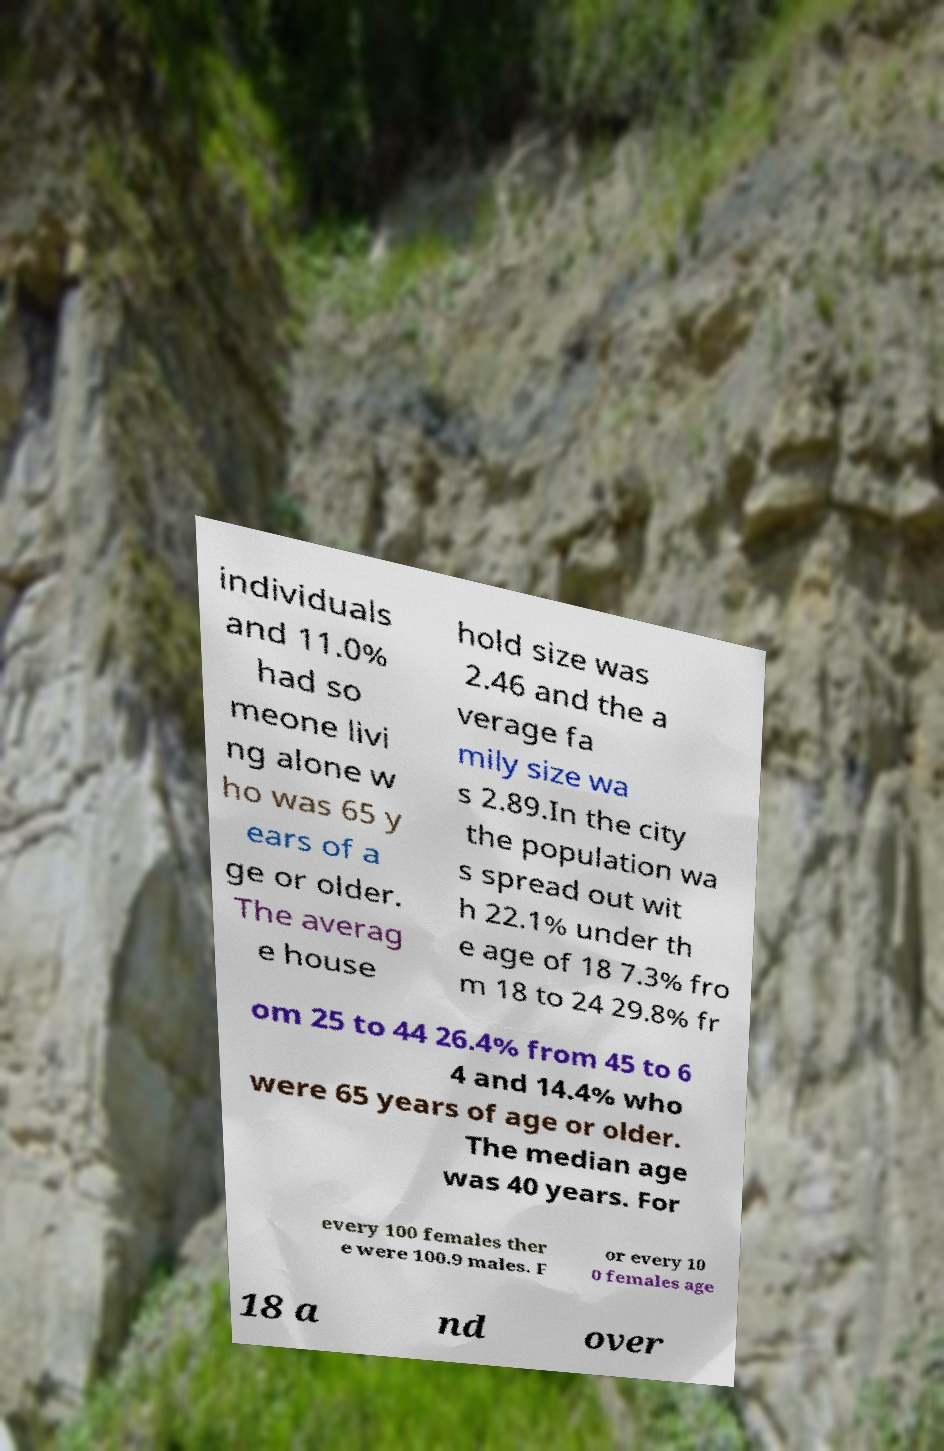Could you assist in decoding the text presented in this image and type it out clearly? individuals and 11.0% had so meone livi ng alone w ho was 65 y ears of a ge or older. The averag e house hold size was 2.46 and the a verage fa mily size wa s 2.89.In the city the population wa s spread out wit h 22.1% under th e age of 18 7.3% fro m 18 to 24 29.8% fr om 25 to 44 26.4% from 45 to 6 4 and 14.4% who were 65 years of age or older. The median age was 40 years. For every 100 females ther e were 100.9 males. F or every 10 0 females age 18 a nd over 